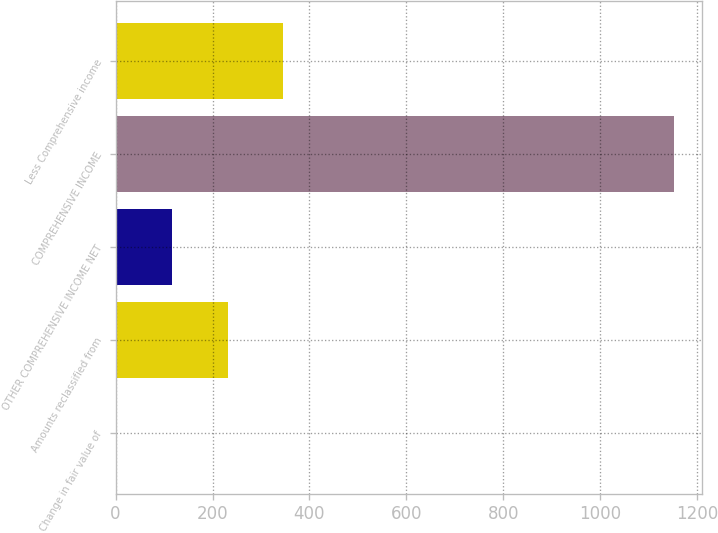<chart> <loc_0><loc_0><loc_500><loc_500><bar_chart><fcel>Change in fair value of<fcel>Amounts reclassified from<fcel>OTHER COMPREHENSIVE INCOME NET<fcel>COMPREHENSIVE INCOME<fcel>Less Comprehensive income<nl><fcel>1<fcel>231.2<fcel>116.1<fcel>1152<fcel>346.3<nl></chart> 